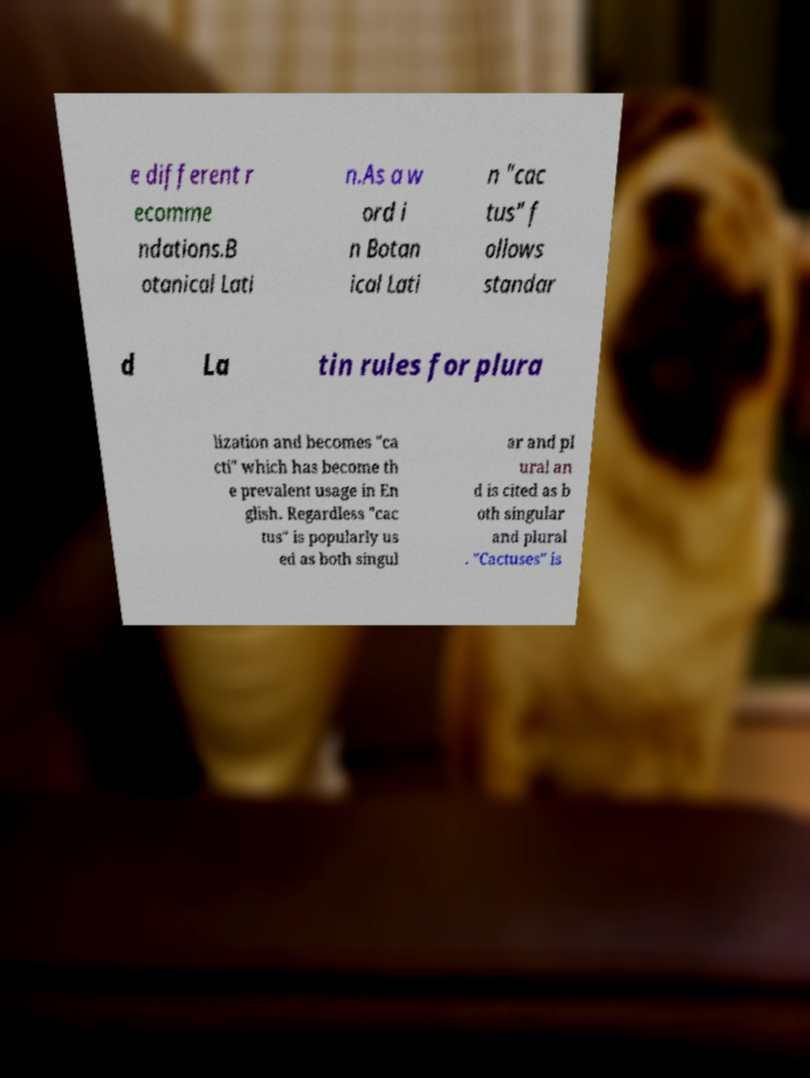There's text embedded in this image that I need extracted. Can you transcribe it verbatim? e different r ecomme ndations.B otanical Lati n.As a w ord i n Botan ical Lati n "cac tus" f ollows standar d La tin rules for plura lization and becomes "ca cti" which has become th e prevalent usage in En glish. Regardless "cac tus" is popularly us ed as both singul ar and pl ural an d is cited as b oth singular and plural . "Cactuses" is 